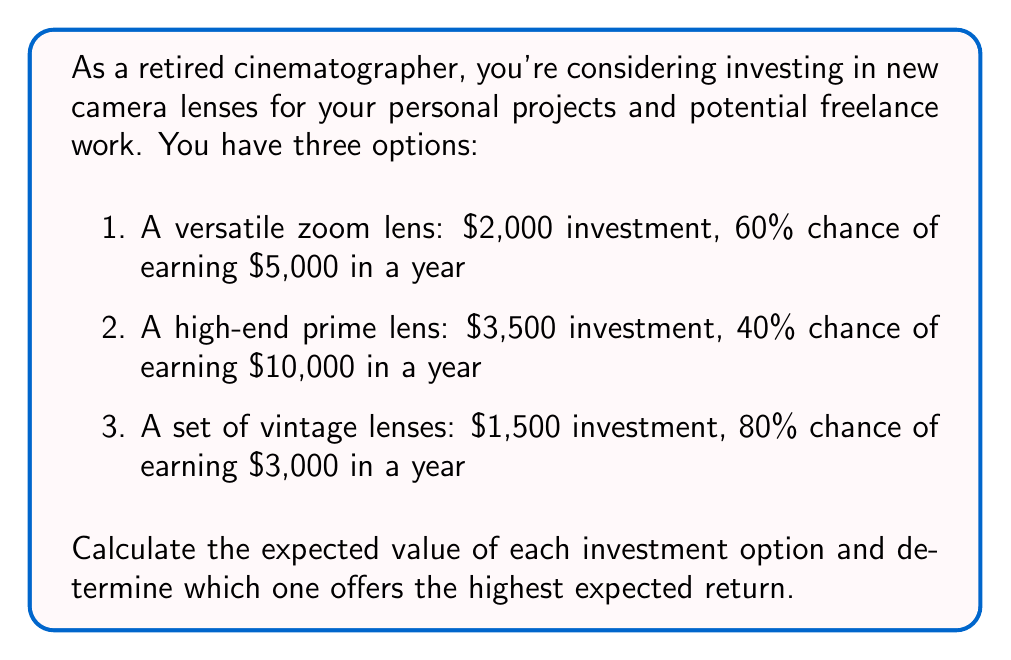Can you solve this math problem? To solve this problem, we need to calculate the expected value for each investment option. The expected value is calculated by multiplying the probability of each outcome by its corresponding value and then summing these products.

For each option, we'll use the formula:
Expected Value = (Probability of success × Potential earnings) - Investment cost

1. Versatile zoom lens:
$$ EV_1 = (0.60 \times \$5,000) - \$2,000 = \$3,000 - \$2,000 = \$1,000 $$

2. High-end prime lens:
$$ EV_2 = (0.40 \times \$10,000) - \$3,500 = \$4,000 - \$3,500 = \$500 $$

3. Set of vintage lenses:
$$ EV_3 = (0.80 \times \$3,000) - \$1,500 = \$2,400 - \$1,500 = \$900 $$

Comparing the expected values:
$EV_1 = \$1,000$
$EV_2 = \$500$
$EV_3 = \$900$

The highest expected value is $\$1,000$, which corresponds to the versatile zoom lens investment option.
Answer: The investment option with the highest expected return is the versatile zoom lens, with an expected value of $\$1,000$. 